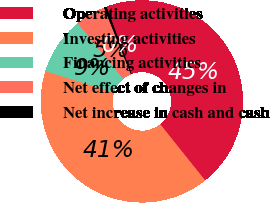<chart> <loc_0><loc_0><loc_500><loc_500><pie_chart><fcel>Operating activities<fcel>Investing activities<fcel>Financing activities<fcel>Net effect of changes in<fcel>Net increase in cash and cash<nl><fcel>44.98%<fcel>40.58%<fcel>9.22%<fcel>4.82%<fcel>0.41%<nl></chart> 